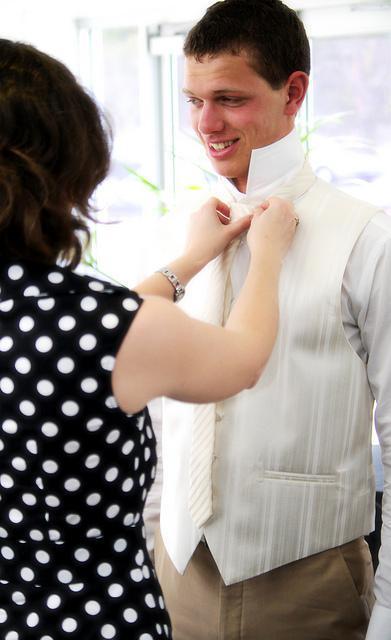What is the woman helping to do?
Answer the question by selecting the correct answer among the 4 following choices.
Options: Burn, tie, cut, feed. Tie. 